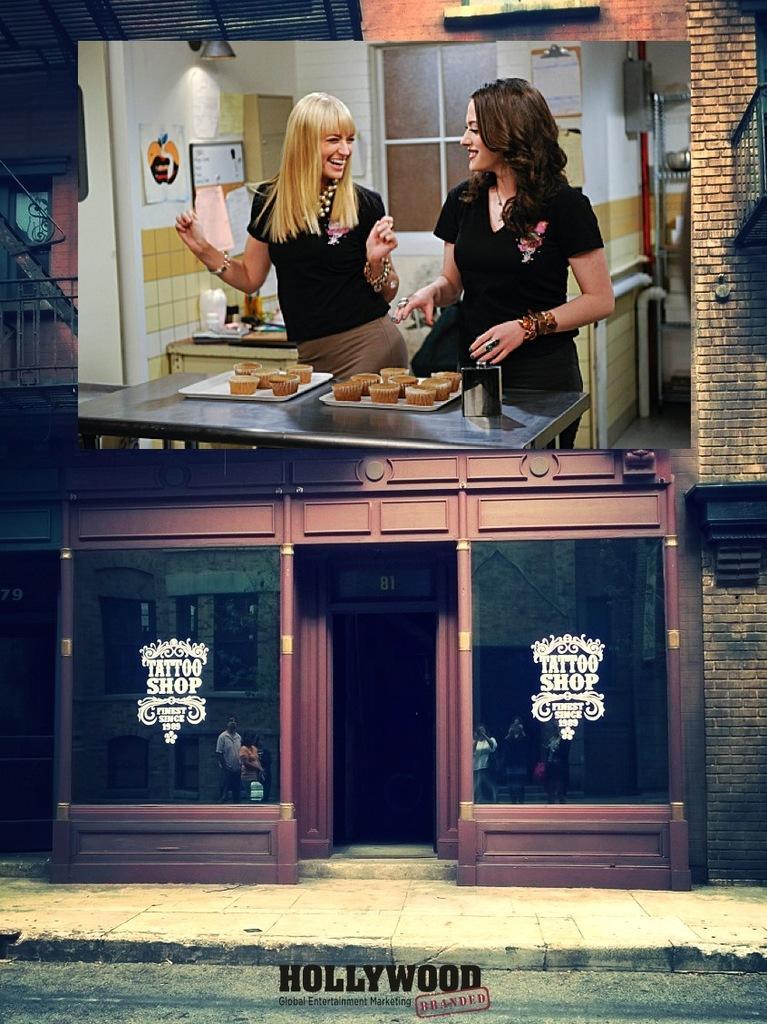Could you give a brief overview of what you see in this image? this picture shows a screen on the store and we see two woman standing with a smile on their faces and we see some food on the table 